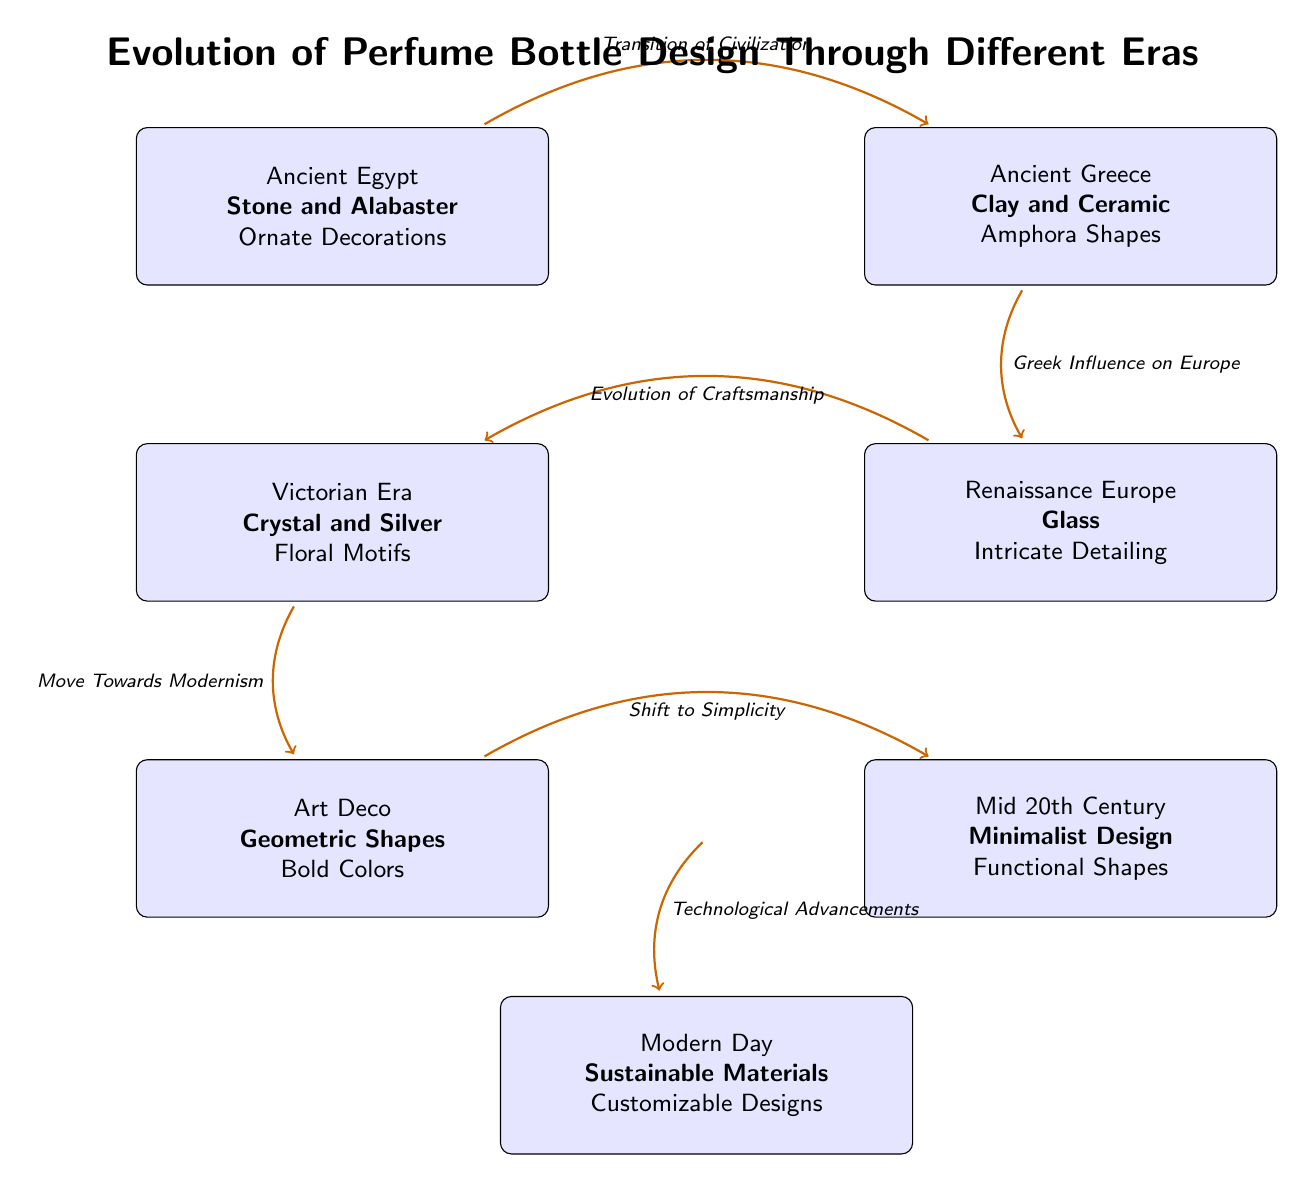What is the key material used during the Victorian Era? The diagram specifically states that the key material used during the Victorian Era is Crystal and Silver
Answer: Crystal and Silver How many major eras are represented in the diagram? By counting each of the labeled nodes in the diagram, we find a total of six significant eras of perfume bottle design
Answer: 6 What design feature is emphasized in the Art Deco era? According to the diagram, the design feature emphasized in the Art Deco era is Geometric Shapes
Answer: Geometric Shapes What era precedes the Mid 20th Century design? Looking at the arrows connecting the nodes, the era directly before Mid 20th Century is Art Deco
Answer: Art Deco What transition describes the move from Victorian Era to Art Deco? The diagram shows that there is a transition labeled Move Towards Modernism that connects the Victorian Era to the Art Deco era
Answer: Move Towards Modernism Which era is characterized by the use of Sustainable Materials? The Modern Day era is specifically indicated in the diagram as the one characterized by Sustainable Materials
Answer: Modern Day What influence is noted between Ancient Greece and Renaissance Europe? The diagram mentions Greek Influence on Europe as the connection between these two eras
Answer: Greek Influence on Europe What is a key design feature of perfume bottles in Renaissance Europe? The diagram clearly indicates that a key feature from the Renaissance Europe era is Intricate Detailing
Answer: Intricate Detailing Which transition indicates the connection between the Art Deco and Modern Day eras? The transition labeled Technological Advancements connects the Art Deco era to the Modern Day
Answer: Technological Advancements 